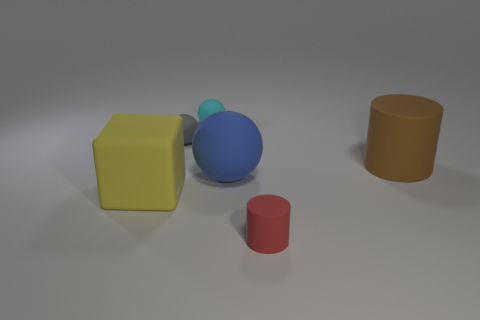Add 1 cylinders. How many objects exist? 7 Subtract all blocks. How many objects are left? 5 Add 6 small gray objects. How many small gray objects are left? 7 Add 2 brown cylinders. How many brown cylinders exist? 3 Subtract 1 yellow cubes. How many objects are left? 5 Subtract all yellow cubes. Subtract all red objects. How many objects are left? 4 